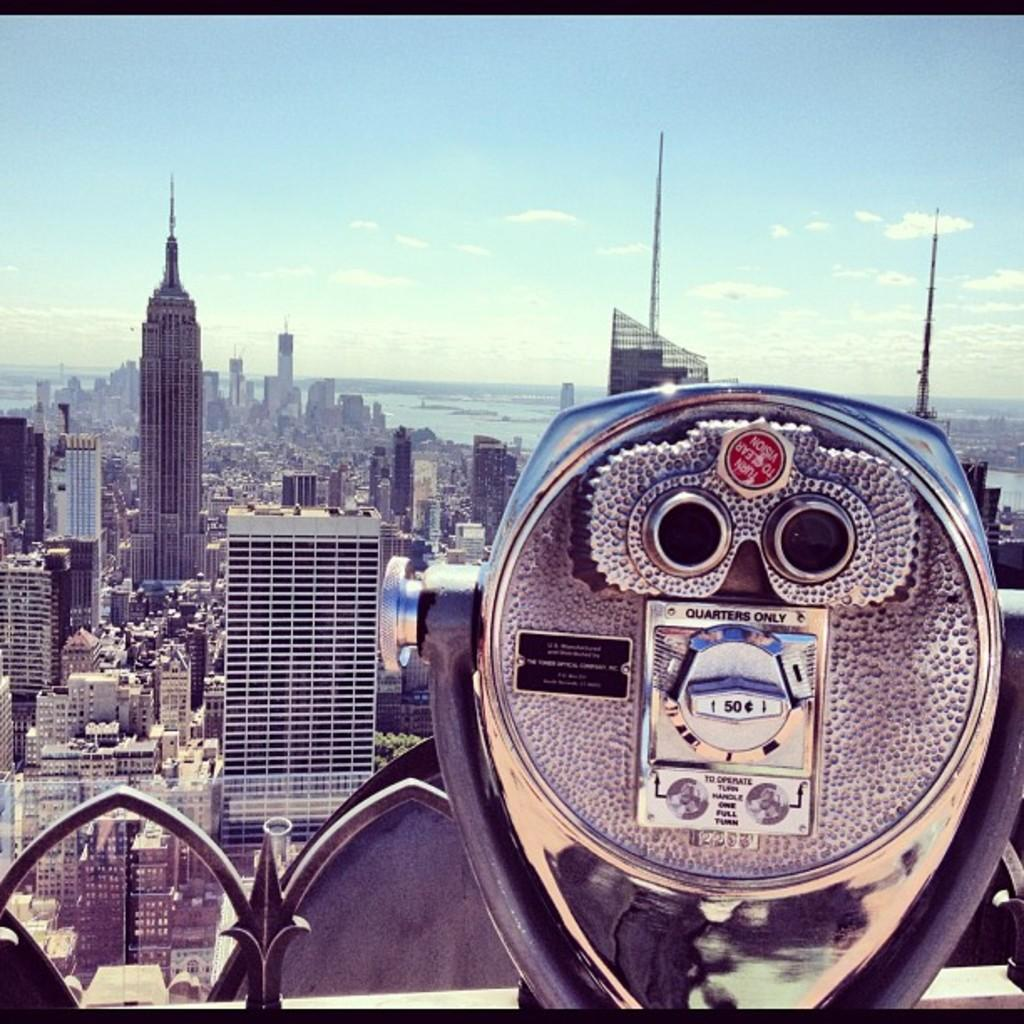What is the main object in the image? There are binoculars in the image. What can be seen in the background of the image? There are buildings, towers, and trees in the background of the image. What is visible in the image besides the binoculars and background? There is water visible in the image. What is visible in the sky at the top of the image? There are clouds in the sky at the top of the image. Can you tell me if the owl in the image has received approval from the local authorities? There is no owl present in the image, so it is not possible to determine if it has received approval from the local authorities. 